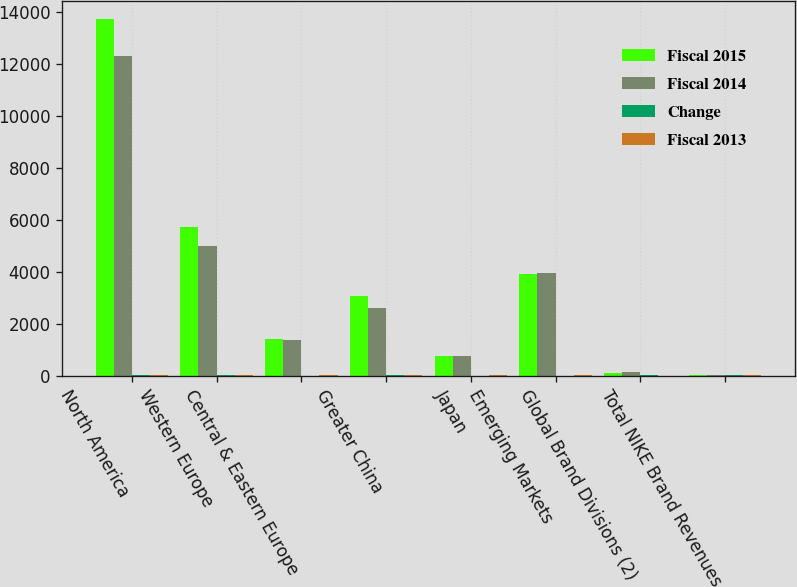Convert chart to OTSL. <chart><loc_0><loc_0><loc_500><loc_500><stacked_bar_chart><ecel><fcel>North America<fcel>Western Europe<fcel>Central & Eastern Europe<fcel>Greater China<fcel>Japan<fcel>Emerging Markets<fcel>Global Brand Divisions (2)<fcel>Total NIKE Brand Revenues<nl><fcel>Fiscal 2015<fcel>13740<fcel>5709<fcel>1417<fcel>3067<fcel>755<fcel>3898<fcel>115<fcel>20<nl><fcel>Fiscal 2014<fcel>12299<fcel>4979<fcel>1387<fcel>2602<fcel>771<fcel>3949<fcel>125<fcel>20<nl><fcel>Change<fcel>12<fcel>15<fcel>2<fcel>18<fcel>2<fcel>1<fcel>8<fcel>10<nl><fcel>Fiscal 2013<fcel>12<fcel>21<fcel>15<fcel>19<fcel>9<fcel>8<fcel>2<fcel>14<nl></chart> 